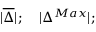Convert formula to latex. <formula><loc_0><loc_0><loc_500><loc_500>| \overline { \Delta } | ; \quad | { \Delta ^ { M a x } } | ;</formula> 